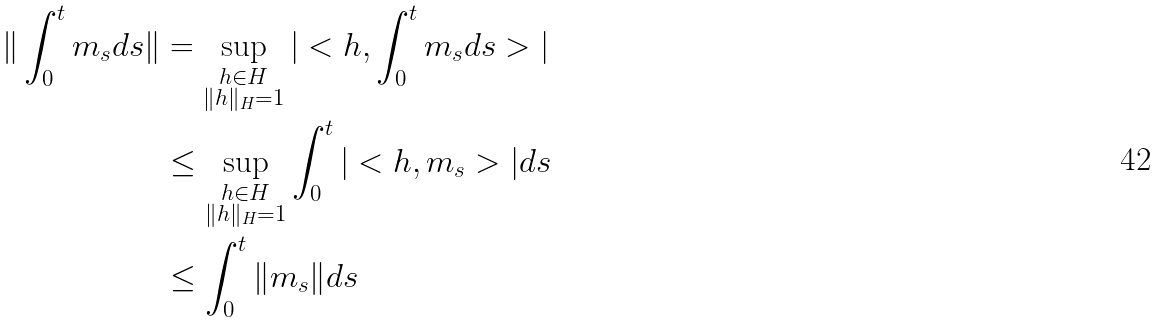Convert formula to latex. <formula><loc_0><loc_0><loc_500><loc_500>\| \int _ { 0 } ^ { t } m _ { s } d s \| & = \sup _ { \substack { h \in H \\ \| h \| _ { H } = 1 } } | < h , \int _ { 0 } ^ { t } m _ { s } d s > | \\ & \leq \sup _ { \substack { h \in H \\ \| h \| _ { H } = 1 } } \int _ { 0 } ^ { t } | < h , m _ { s } > | d s \\ & \leq \int _ { 0 } ^ { t } \| m _ { s } \| d s</formula> 